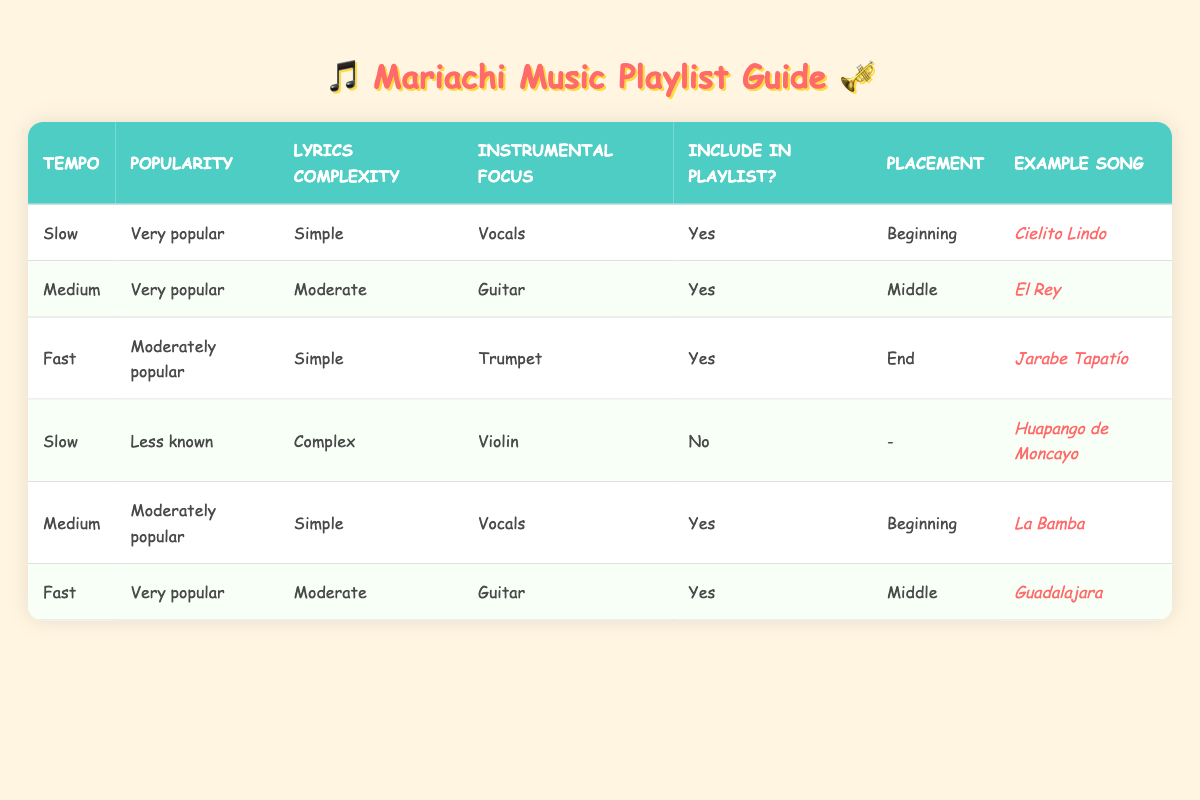What is the example song listed for a slow tempo, very popular, simple lyrics, and vocal focus? In the table, we look for the row where the tempo is "Slow," the popularity is "Very popular," the lyrics complexity is "Simple," and the instrumental focus is "Vocals." This matches the conditions in the first row, where the example song is "Cielito Lindo."
Answer: Cielito Lindo How many songs are recommended for the playlist with a fast tempo? To find the number of recommended songs for a fast tempo, we need to count the rows where "Tempo" is "Fast" and "Include in Playlist" is "Yes." In the table, there are two entries for "Fast" that meet this condition: "Jarabe Tapatío" and "Guadalajara." Thus, the total is 2.
Answer: 2 Is "Huapango de Moncayo" included in the playlist? We check the entry for "Huapango de Moncayo" in the table. It is listed under the conditions of "Slow," "Less known," "Complex," and "Violin." The action states "No" for "Include in Playlist," confirming that it is not included.
Answer: No Which song is placed in the middle of the playlist for a medium tempo and very popular song with a guitar focus? We need to locate the row with "Medium" tempo, "Very popular," "Moderate" lyrics complexity, and "Guitar" focus. This matches the second row, indicating that the song "El Rey" is placed in the middle of the playlist.
Answer: El Rey Which two placements are identified for songs with a medium tempo? We look for all entries that note "Medium" in the tempo column. There are two applicable rows: one song, "El Rey," is placed in the middle and another, "La Bamba," is placed at the beginning. Summarizing these findings indicates the placements are "Beginning" and "Middle."
Answer: Beginning, Middle If you wanted a song with simple lyrics complexity, what temperature should you choose to ensure it is included? We need to analyze the rows with "Simple" as the lyrics complexity and check the placements of these songs. The findings show songs with simple lyrics complexity in a "Slow," "Fast," or "Medium" tempo are all included, meaning selecting any of these tempos can yield a song with simple lyrics.
Answer: Slow, Medium, Fast What is the song that would be at the end of the playlist if you prefer fast tempo and moderately popular status? We locate all entries with "Fast" tempo and "Moderately popular" in the table. The only relevant entry shows that "Jarabe Tapatío" is the song to be included at the end of the playlist, thus our answer reflects this.
Answer: Jarabe Tapatío What is the common placement for songs that are very popular and have a slow tempo? In the table, we should check for entries with "Very popular" and "Slow" tempo. The only song satisfying these conditions is "Cielito Lindo," which is specifically placed at the beginning. Therefore, the common placement is the beginning.
Answer: Beginning How many songs do not get included in the playlist? We'll count the total songs where "Include in Playlist" is "No." From the table, we find one song identified as "Huapango de Moncayo" that is not included in the playlist, resulting in a total of 1 song not included.
Answer: 1 